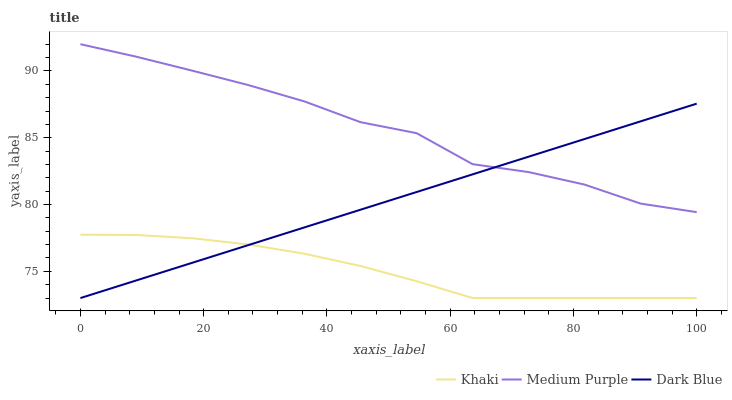Does Khaki have the minimum area under the curve?
Answer yes or no. Yes. Does Medium Purple have the maximum area under the curve?
Answer yes or no. Yes. Does Dark Blue have the minimum area under the curve?
Answer yes or no. No. Does Dark Blue have the maximum area under the curve?
Answer yes or no. No. Is Dark Blue the smoothest?
Answer yes or no. Yes. Is Medium Purple the roughest?
Answer yes or no. Yes. Is Khaki the smoothest?
Answer yes or no. No. Is Khaki the roughest?
Answer yes or no. No. Does Dark Blue have the highest value?
Answer yes or no. No. Is Khaki less than Medium Purple?
Answer yes or no. Yes. Is Medium Purple greater than Khaki?
Answer yes or no. Yes. Does Khaki intersect Medium Purple?
Answer yes or no. No. 